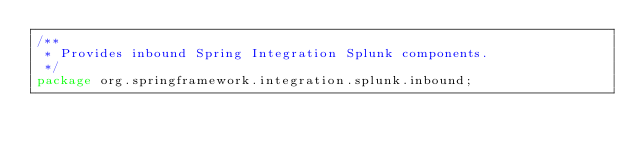<code> <loc_0><loc_0><loc_500><loc_500><_Java_>/**
 * Provides inbound Spring Integration Splunk components.
 */
package org.springframework.integration.splunk.inbound;
</code> 